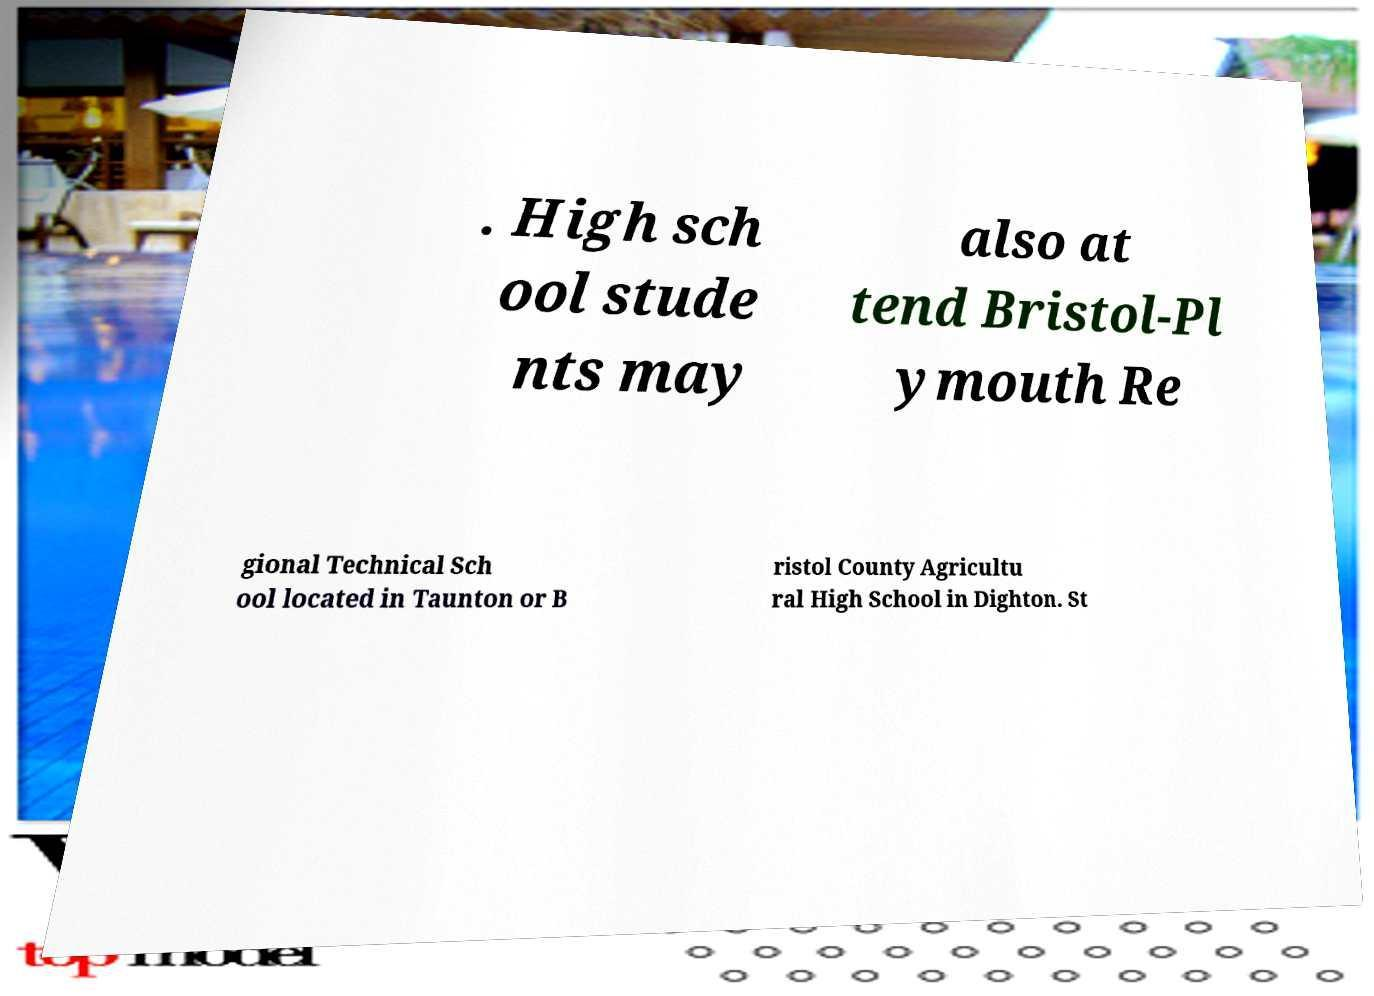There's text embedded in this image that I need extracted. Can you transcribe it verbatim? . High sch ool stude nts may also at tend Bristol-Pl ymouth Re gional Technical Sch ool located in Taunton or B ristol County Agricultu ral High School in Dighton. St 